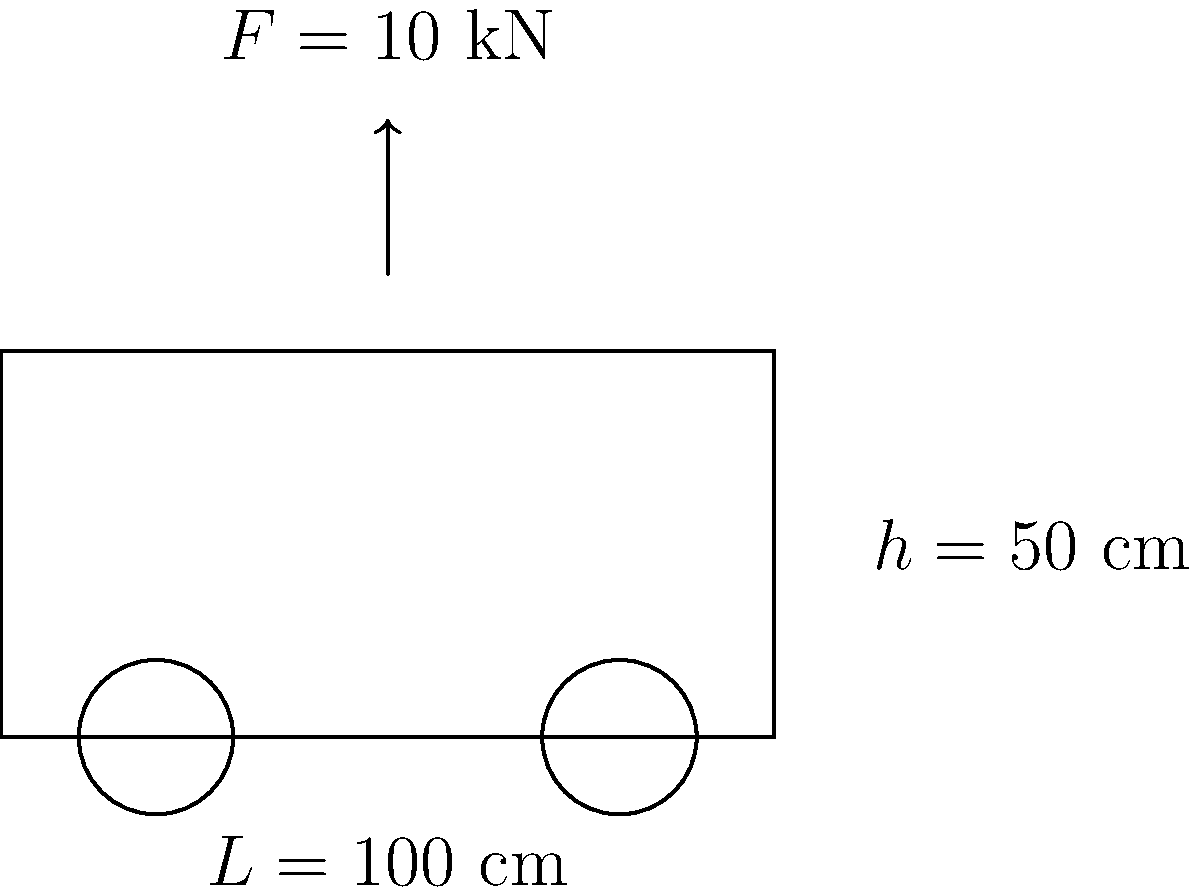A ceremonial carriage used in royal processions is subjected to a vertical force of 10 kN at its center. The carriage has a length of 100 cm and a height of 50 cm. Assuming the carriage can be modeled as a simple beam, calculate the maximum bending stress experienced by the carriage. The carriage is made of oak wood with a rectangular cross-section of 10 cm x 20 cm (width x height). To solve this problem, we'll follow these steps:

1. Calculate the moment of inertia (I) of the cross-section:
   $$I = \frac{1}{12} \cdot b \cdot h^3 = \frac{1}{12} \cdot 10 \text{ cm} \cdot (20 \text{ cm})^3 = 6666.67 \text{ cm}^4$$

2. Determine the maximum bending moment (M):
   The maximum bending moment occurs at the center of the beam.
   $$M = \frac{F \cdot L}{4} = \frac{10 \text{ kN} \cdot 100 \text{ cm}}{4} = 250 \text{ kN·cm}$$

3. Calculate the distance from the neutral axis to the outermost fiber (c):
   $$c = \frac{h}{2} = \frac{20 \text{ cm}}{2} = 10 \text{ cm}$$

4. Apply the bending stress formula:
   $$\sigma_{max} = \frac{M \cdot c}{I} = \frac{250 \text{ kN·cm} \cdot 10 \text{ cm}}{6666.67 \text{ cm}^4} = 3.75 \text{ kN/cm}^2 = 37.5 \text{ MPa}$$

Therefore, the maximum bending stress experienced by the carriage is 37.5 MPa.
Answer: 37.5 MPa 